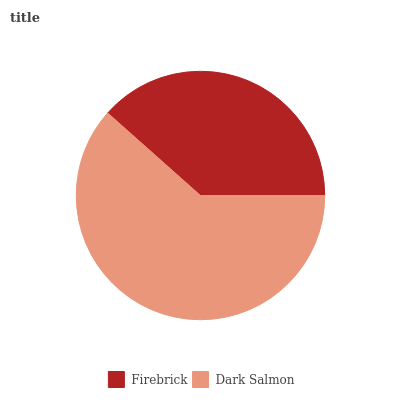Is Firebrick the minimum?
Answer yes or no. Yes. Is Dark Salmon the maximum?
Answer yes or no. Yes. Is Dark Salmon the minimum?
Answer yes or no. No. Is Dark Salmon greater than Firebrick?
Answer yes or no. Yes. Is Firebrick less than Dark Salmon?
Answer yes or no. Yes. Is Firebrick greater than Dark Salmon?
Answer yes or no. No. Is Dark Salmon less than Firebrick?
Answer yes or no. No. Is Dark Salmon the high median?
Answer yes or no. Yes. Is Firebrick the low median?
Answer yes or no. Yes. Is Firebrick the high median?
Answer yes or no. No. Is Dark Salmon the low median?
Answer yes or no. No. 